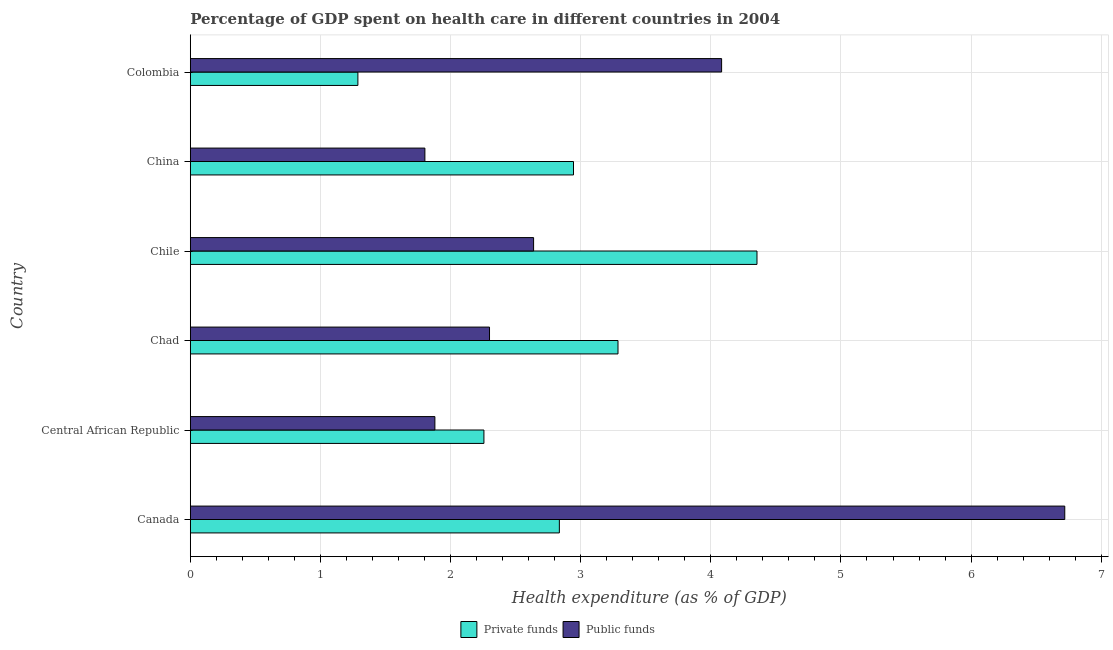How many different coloured bars are there?
Provide a short and direct response. 2. How many groups of bars are there?
Offer a very short reply. 6. Are the number of bars per tick equal to the number of legend labels?
Offer a very short reply. Yes. Are the number of bars on each tick of the Y-axis equal?
Your answer should be compact. Yes. How many bars are there on the 4th tick from the bottom?
Keep it short and to the point. 2. What is the amount of public funds spent in healthcare in Chile?
Offer a very short reply. 2.64. Across all countries, what is the maximum amount of private funds spent in healthcare?
Ensure brevity in your answer.  4.35. Across all countries, what is the minimum amount of private funds spent in healthcare?
Your response must be concise. 1.29. In which country was the amount of public funds spent in healthcare maximum?
Your answer should be compact. Canada. What is the total amount of private funds spent in healthcare in the graph?
Your response must be concise. 16.97. What is the difference between the amount of private funds spent in healthcare in Canada and that in Chile?
Your answer should be very brief. -1.52. What is the difference between the amount of private funds spent in healthcare in Canada and the amount of public funds spent in healthcare in Chile?
Offer a very short reply. 0.2. What is the average amount of private funds spent in healthcare per country?
Make the answer very short. 2.83. What is the difference between the amount of public funds spent in healthcare and amount of private funds spent in healthcare in China?
Provide a short and direct response. -1.14. In how many countries, is the amount of private funds spent in healthcare greater than 5.8 %?
Offer a very short reply. 0. What is the ratio of the amount of private funds spent in healthcare in Canada to that in China?
Make the answer very short. 0.96. Is the difference between the amount of private funds spent in healthcare in Chad and Colombia greater than the difference between the amount of public funds spent in healthcare in Chad and Colombia?
Offer a terse response. Yes. What is the difference between the highest and the second highest amount of private funds spent in healthcare?
Offer a terse response. 1.07. What is the difference between the highest and the lowest amount of private funds spent in healthcare?
Ensure brevity in your answer.  3.07. What does the 1st bar from the top in China represents?
Your response must be concise. Public funds. What does the 2nd bar from the bottom in Canada represents?
Provide a short and direct response. Public funds. Are all the bars in the graph horizontal?
Ensure brevity in your answer.  Yes. How many legend labels are there?
Ensure brevity in your answer.  2. How are the legend labels stacked?
Give a very brief answer. Horizontal. What is the title of the graph?
Make the answer very short. Percentage of GDP spent on health care in different countries in 2004. Does "Urban Population" appear as one of the legend labels in the graph?
Give a very brief answer. No. What is the label or title of the X-axis?
Provide a succinct answer. Health expenditure (as % of GDP). What is the label or title of the Y-axis?
Your response must be concise. Country. What is the Health expenditure (as % of GDP) in Private funds in Canada?
Provide a short and direct response. 2.84. What is the Health expenditure (as % of GDP) in Public funds in Canada?
Give a very brief answer. 6.72. What is the Health expenditure (as % of GDP) of Private funds in Central African Republic?
Provide a short and direct response. 2.26. What is the Health expenditure (as % of GDP) of Public funds in Central African Republic?
Offer a terse response. 1.88. What is the Health expenditure (as % of GDP) in Private funds in Chad?
Keep it short and to the point. 3.29. What is the Health expenditure (as % of GDP) of Public funds in Chad?
Give a very brief answer. 2.3. What is the Health expenditure (as % of GDP) of Private funds in Chile?
Ensure brevity in your answer.  4.35. What is the Health expenditure (as % of GDP) of Public funds in Chile?
Your response must be concise. 2.64. What is the Health expenditure (as % of GDP) in Private funds in China?
Ensure brevity in your answer.  2.94. What is the Health expenditure (as % of GDP) of Public funds in China?
Provide a short and direct response. 1.8. What is the Health expenditure (as % of GDP) in Private funds in Colombia?
Keep it short and to the point. 1.29. What is the Health expenditure (as % of GDP) of Public funds in Colombia?
Give a very brief answer. 4.08. Across all countries, what is the maximum Health expenditure (as % of GDP) of Private funds?
Your answer should be compact. 4.35. Across all countries, what is the maximum Health expenditure (as % of GDP) in Public funds?
Ensure brevity in your answer.  6.72. Across all countries, what is the minimum Health expenditure (as % of GDP) of Private funds?
Offer a terse response. 1.29. Across all countries, what is the minimum Health expenditure (as % of GDP) of Public funds?
Your answer should be compact. 1.8. What is the total Health expenditure (as % of GDP) in Private funds in the graph?
Offer a terse response. 16.97. What is the total Health expenditure (as % of GDP) in Public funds in the graph?
Provide a succinct answer. 19.42. What is the difference between the Health expenditure (as % of GDP) in Private funds in Canada and that in Central African Republic?
Offer a terse response. 0.58. What is the difference between the Health expenditure (as % of GDP) in Public funds in Canada and that in Central African Republic?
Ensure brevity in your answer.  4.84. What is the difference between the Health expenditure (as % of GDP) in Private funds in Canada and that in Chad?
Provide a short and direct response. -0.45. What is the difference between the Health expenditure (as % of GDP) in Public funds in Canada and that in Chad?
Your answer should be very brief. 4.42. What is the difference between the Health expenditure (as % of GDP) of Private funds in Canada and that in Chile?
Make the answer very short. -1.52. What is the difference between the Health expenditure (as % of GDP) in Public funds in Canada and that in Chile?
Provide a short and direct response. 4.08. What is the difference between the Health expenditure (as % of GDP) of Private funds in Canada and that in China?
Offer a very short reply. -0.11. What is the difference between the Health expenditure (as % of GDP) of Public funds in Canada and that in China?
Your response must be concise. 4.92. What is the difference between the Health expenditure (as % of GDP) of Private funds in Canada and that in Colombia?
Provide a short and direct response. 1.55. What is the difference between the Health expenditure (as % of GDP) in Public funds in Canada and that in Colombia?
Offer a very short reply. 2.64. What is the difference between the Health expenditure (as % of GDP) of Private funds in Central African Republic and that in Chad?
Offer a very short reply. -1.03. What is the difference between the Health expenditure (as % of GDP) of Public funds in Central African Republic and that in Chad?
Provide a short and direct response. -0.42. What is the difference between the Health expenditure (as % of GDP) of Private funds in Central African Republic and that in Chile?
Your answer should be compact. -2.1. What is the difference between the Health expenditure (as % of GDP) in Public funds in Central African Republic and that in Chile?
Your response must be concise. -0.76. What is the difference between the Health expenditure (as % of GDP) in Private funds in Central African Republic and that in China?
Provide a short and direct response. -0.69. What is the difference between the Health expenditure (as % of GDP) of Public funds in Central African Republic and that in China?
Give a very brief answer. 0.08. What is the difference between the Health expenditure (as % of GDP) in Private funds in Central African Republic and that in Colombia?
Your answer should be compact. 0.97. What is the difference between the Health expenditure (as % of GDP) of Public funds in Central African Republic and that in Colombia?
Ensure brevity in your answer.  -2.2. What is the difference between the Health expenditure (as % of GDP) in Private funds in Chad and that in Chile?
Ensure brevity in your answer.  -1.07. What is the difference between the Health expenditure (as % of GDP) of Public funds in Chad and that in Chile?
Offer a terse response. -0.34. What is the difference between the Health expenditure (as % of GDP) in Private funds in Chad and that in China?
Make the answer very short. 0.34. What is the difference between the Health expenditure (as % of GDP) of Public funds in Chad and that in China?
Offer a very short reply. 0.5. What is the difference between the Health expenditure (as % of GDP) of Private funds in Chad and that in Colombia?
Your response must be concise. 2. What is the difference between the Health expenditure (as % of GDP) in Public funds in Chad and that in Colombia?
Your answer should be very brief. -1.78. What is the difference between the Health expenditure (as % of GDP) in Private funds in Chile and that in China?
Your answer should be very brief. 1.41. What is the difference between the Health expenditure (as % of GDP) of Public funds in Chile and that in China?
Your answer should be compact. 0.84. What is the difference between the Health expenditure (as % of GDP) in Private funds in Chile and that in Colombia?
Your answer should be very brief. 3.07. What is the difference between the Health expenditure (as % of GDP) in Public funds in Chile and that in Colombia?
Make the answer very short. -1.44. What is the difference between the Health expenditure (as % of GDP) in Private funds in China and that in Colombia?
Provide a short and direct response. 1.66. What is the difference between the Health expenditure (as % of GDP) of Public funds in China and that in Colombia?
Offer a very short reply. -2.28. What is the difference between the Health expenditure (as % of GDP) of Private funds in Canada and the Health expenditure (as % of GDP) of Public funds in Central African Republic?
Ensure brevity in your answer.  0.96. What is the difference between the Health expenditure (as % of GDP) in Private funds in Canada and the Health expenditure (as % of GDP) in Public funds in Chad?
Ensure brevity in your answer.  0.54. What is the difference between the Health expenditure (as % of GDP) of Private funds in Canada and the Health expenditure (as % of GDP) of Public funds in Chile?
Provide a succinct answer. 0.2. What is the difference between the Health expenditure (as % of GDP) of Private funds in Canada and the Health expenditure (as % of GDP) of Public funds in China?
Provide a short and direct response. 1.03. What is the difference between the Health expenditure (as % of GDP) of Private funds in Canada and the Health expenditure (as % of GDP) of Public funds in Colombia?
Make the answer very short. -1.25. What is the difference between the Health expenditure (as % of GDP) in Private funds in Central African Republic and the Health expenditure (as % of GDP) in Public funds in Chad?
Make the answer very short. -0.04. What is the difference between the Health expenditure (as % of GDP) of Private funds in Central African Republic and the Health expenditure (as % of GDP) of Public funds in Chile?
Provide a succinct answer. -0.38. What is the difference between the Health expenditure (as % of GDP) of Private funds in Central African Republic and the Health expenditure (as % of GDP) of Public funds in China?
Provide a succinct answer. 0.45. What is the difference between the Health expenditure (as % of GDP) of Private funds in Central African Republic and the Health expenditure (as % of GDP) of Public funds in Colombia?
Provide a succinct answer. -1.83. What is the difference between the Health expenditure (as % of GDP) in Private funds in Chad and the Health expenditure (as % of GDP) in Public funds in Chile?
Make the answer very short. 0.65. What is the difference between the Health expenditure (as % of GDP) of Private funds in Chad and the Health expenditure (as % of GDP) of Public funds in China?
Provide a short and direct response. 1.48. What is the difference between the Health expenditure (as % of GDP) in Private funds in Chad and the Health expenditure (as % of GDP) in Public funds in Colombia?
Your response must be concise. -0.8. What is the difference between the Health expenditure (as % of GDP) in Private funds in Chile and the Health expenditure (as % of GDP) in Public funds in China?
Your response must be concise. 2.55. What is the difference between the Health expenditure (as % of GDP) in Private funds in Chile and the Health expenditure (as % of GDP) in Public funds in Colombia?
Offer a very short reply. 0.27. What is the difference between the Health expenditure (as % of GDP) in Private funds in China and the Health expenditure (as % of GDP) in Public funds in Colombia?
Provide a succinct answer. -1.14. What is the average Health expenditure (as % of GDP) of Private funds per country?
Your answer should be compact. 2.83. What is the average Health expenditure (as % of GDP) in Public funds per country?
Your answer should be compact. 3.24. What is the difference between the Health expenditure (as % of GDP) of Private funds and Health expenditure (as % of GDP) of Public funds in Canada?
Ensure brevity in your answer.  -3.88. What is the difference between the Health expenditure (as % of GDP) in Private funds and Health expenditure (as % of GDP) in Public funds in Central African Republic?
Your response must be concise. 0.38. What is the difference between the Health expenditure (as % of GDP) in Private funds and Health expenditure (as % of GDP) in Public funds in Chad?
Give a very brief answer. 0.99. What is the difference between the Health expenditure (as % of GDP) in Private funds and Health expenditure (as % of GDP) in Public funds in Chile?
Provide a succinct answer. 1.72. What is the difference between the Health expenditure (as % of GDP) in Private funds and Health expenditure (as % of GDP) in Public funds in China?
Offer a terse response. 1.14. What is the difference between the Health expenditure (as % of GDP) of Private funds and Health expenditure (as % of GDP) of Public funds in Colombia?
Your response must be concise. -2.79. What is the ratio of the Health expenditure (as % of GDP) in Private funds in Canada to that in Central African Republic?
Give a very brief answer. 1.26. What is the ratio of the Health expenditure (as % of GDP) in Public funds in Canada to that in Central African Republic?
Your answer should be very brief. 3.58. What is the ratio of the Health expenditure (as % of GDP) of Private funds in Canada to that in Chad?
Your response must be concise. 0.86. What is the ratio of the Health expenditure (as % of GDP) in Public funds in Canada to that in Chad?
Your answer should be compact. 2.92. What is the ratio of the Health expenditure (as % of GDP) of Private funds in Canada to that in Chile?
Your answer should be very brief. 0.65. What is the ratio of the Health expenditure (as % of GDP) of Public funds in Canada to that in Chile?
Ensure brevity in your answer.  2.55. What is the ratio of the Health expenditure (as % of GDP) in Private funds in Canada to that in China?
Ensure brevity in your answer.  0.96. What is the ratio of the Health expenditure (as % of GDP) of Public funds in Canada to that in China?
Give a very brief answer. 3.73. What is the ratio of the Health expenditure (as % of GDP) of Private funds in Canada to that in Colombia?
Your answer should be very brief. 2.2. What is the ratio of the Health expenditure (as % of GDP) in Public funds in Canada to that in Colombia?
Provide a succinct answer. 1.65. What is the ratio of the Health expenditure (as % of GDP) of Private funds in Central African Republic to that in Chad?
Ensure brevity in your answer.  0.69. What is the ratio of the Health expenditure (as % of GDP) of Public funds in Central African Republic to that in Chad?
Give a very brief answer. 0.82. What is the ratio of the Health expenditure (as % of GDP) of Private funds in Central African Republic to that in Chile?
Keep it short and to the point. 0.52. What is the ratio of the Health expenditure (as % of GDP) in Public funds in Central African Republic to that in Chile?
Ensure brevity in your answer.  0.71. What is the ratio of the Health expenditure (as % of GDP) in Private funds in Central African Republic to that in China?
Provide a succinct answer. 0.77. What is the ratio of the Health expenditure (as % of GDP) in Public funds in Central African Republic to that in China?
Offer a terse response. 1.04. What is the ratio of the Health expenditure (as % of GDP) of Private funds in Central African Republic to that in Colombia?
Your answer should be compact. 1.75. What is the ratio of the Health expenditure (as % of GDP) of Public funds in Central African Republic to that in Colombia?
Offer a very short reply. 0.46. What is the ratio of the Health expenditure (as % of GDP) of Private funds in Chad to that in Chile?
Your answer should be very brief. 0.75. What is the ratio of the Health expenditure (as % of GDP) in Public funds in Chad to that in Chile?
Your answer should be compact. 0.87. What is the ratio of the Health expenditure (as % of GDP) in Private funds in Chad to that in China?
Give a very brief answer. 1.12. What is the ratio of the Health expenditure (as % of GDP) of Public funds in Chad to that in China?
Offer a very short reply. 1.28. What is the ratio of the Health expenditure (as % of GDP) of Private funds in Chad to that in Colombia?
Your answer should be compact. 2.55. What is the ratio of the Health expenditure (as % of GDP) in Public funds in Chad to that in Colombia?
Keep it short and to the point. 0.56. What is the ratio of the Health expenditure (as % of GDP) in Private funds in Chile to that in China?
Offer a terse response. 1.48. What is the ratio of the Health expenditure (as % of GDP) of Public funds in Chile to that in China?
Your response must be concise. 1.46. What is the ratio of the Health expenditure (as % of GDP) of Private funds in Chile to that in Colombia?
Provide a short and direct response. 3.38. What is the ratio of the Health expenditure (as % of GDP) of Public funds in Chile to that in Colombia?
Ensure brevity in your answer.  0.65. What is the ratio of the Health expenditure (as % of GDP) in Private funds in China to that in Colombia?
Provide a succinct answer. 2.29. What is the ratio of the Health expenditure (as % of GDP) in Public funds in China to that in Colombia?
Provide a succinct answer. 0.44. What is the difference between the highest and the second highest Health expenditure (as % of GDP) of Private funds?
Your answer should be very brief. 1.07. What is the difference between the highest and the second highest Health expenditure (as % of GDP) in Public funds?
Make the answer very short. 2.64. What is the difference between the highest and the lowest Health expenditure (as % of GDP) in Private funds?
Keep it short and to the point. 3.07. What is the difference between the highest and the lowest Health expenditure (as % of GDP) of Public funds?
Keep it short and to the point. 4.92. 